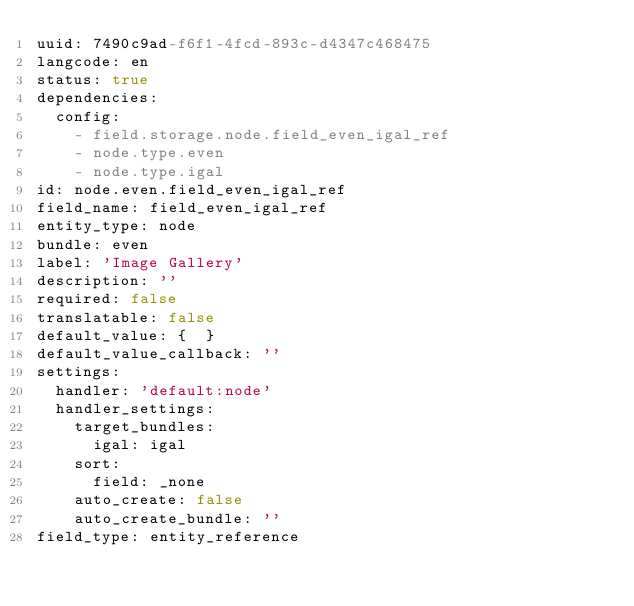<code> <loc_0><loc_0><loc_500><loc_500><_YAML_>uuid: 7490c9ad-f6f1-4fcd-893c-d4347c468475
langcode: en
status: true
dependencies:
  config:
    - field.storage.node.field_even_igal_ref
    - node.type.even
    - node.type.igal
id: node.even.field_even_igal_ref
field_name: field_even_igal_ref
entity_type: node
bundle: even
label: 'Image Gallery'
description: ''
required: false
translatable: false
default_value: {  }
default_value_callback: ''
settings:
  handler: 'default:node'
  handler_settings:
    target_bundles:
      igal: igal
    sort:
      field: _none
    auto_create: false
    auto_create_bundle: ''
field_type: entity_reference
</code> 